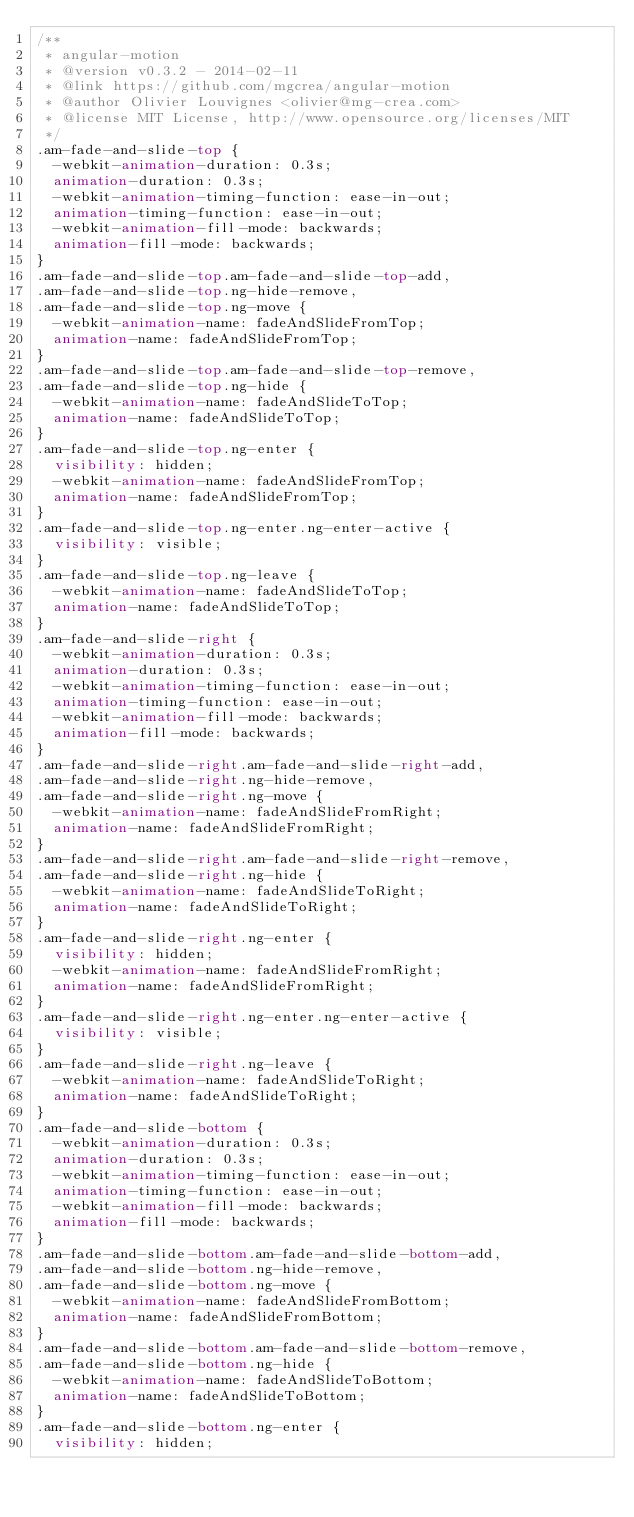Convert code to text. <code><loc_0><loc_0><loc_500><loc_500><_CSS_>/**
 * angular-motion
 * @version v0.3.2 - 2014-02-11
 * @link https://github.com/mgcrea/angular-motion
 * @author Olivier Louvignes <olivier@mg-crea.com>
 * @license MIT License, http://www.opensource.org/licenses/MIT
 */
.am-fade-and-slide-top {
  -webkit-animation-duration: 0.3s;
  animation-duration: 0.3s;
  -webkit-animation-timing-function: ease-in-out;
  animation-timing-function: ease-in-out;
  -webkit-animation-fill-mode: backwards;
  animation-fill-mode: backwards;
}
.am-fade-and-slide-top.am-fade-and-slide-top-add,
.am-fade-and-slide-top.ng-hide-remove,
.am-fade-and-slide-top.ng-move {
  -webkit-animation-name: fadeAndSlideFromTop;
  animation-name: fadeAndSlideFromTop;
}
.am-fade-and-slide-top.am-fade-and-slide-top-remove,
.am-fade-and-slide-top.ng-hide {
  -webkit-animation-name: fadeAndSlideToTop;
  animation-name: fadeAndSlideToTop;
}
.am-fade-and-slide-top.ng-enter {
  visibility: hidden;
  -webkit-animation-name: fadeAndSlideFromTop;
  animation-name: fadeAndSlideFromTop;
}
.am-fade-and-slide-top.ng-enter.ng-enter-active {
  visibility: visible;
}
.am-fade-and-slide-top.ng-leave {
  -webkit-animation-name: fadeAndSlideToTop;
  animation-name: fadeAndSlideToTop;
}
.am-fade-and-slide-right {
  -webkit-animation-duration: 0.3s;
  animation-duration: 0.3s;
  -webkit-animation-timing-function: ease-in-out;
  animation-timing-function: ease-in-out;
  -webkit-animation-fill-mode: backwards;
  animation-fill-mode: backwards;
}
.am-fade-and-slide-right.am-fade-and-slide-right-add,
.am-fade-and-slide-right.ng-hide-remove,
.am-fade-and-slide-right.ng-move {
  -webkit-animation-name: fadeAndSlideFromRight;
  animation-name: fadeAndSlideFromRight;
}
.am-fade-and-slide-right.am-fade-and-slide-right-remove,
.am-fade-and-slide-right.ng-hide {
  -webkit-animation-name: fadeAndSlideToRight;
  animation-name: fadeAndSlideToRight;
}
.am-fade-and-slide-right.ng-enter {
  visibility: hidden;
  -webkit-animation-name: fadeAndSlideFromRight;
  animation-name: fadeAndSlideFromRight;
}
.am-fade-and-slide-right.ng-enter.ng-enter-active {
  visibility: visible;
}
.am-fade-and-slide-right.ng-leave {
  -webkit-animation-name: fadeAndSlideToRight;
  animation-name: fadeAndSlideToRight;
}
.am-fade-and-slide-bottom {
  -webkit-animation-duration: 0.3s;
  animation-duration: 0.3s;
  -webkit-animation-timing-function: ease-in-out;
  animation-timing-function: ease-in-out;
  -webkit-animation-fill-mode: backwards;
  animation-fill-mode: backwards;
}
.am-fade-and-slide-bottom.am-fade-and-slide-bottom-add,
.am-fade-and-slide-bottom.ng-hide-remove,
.am-fade-and-slide-bottom.ng-move {
  -webkit-animation-name: fadeAndSlideFromBottom;
  animation-name: fadeAndSlideFromBottom;
}
.am-fade-and-slide-bottom.am-fade-and-slide-bottom-remove,
.am-fade-and-slide-bottom.ng-hide {
  -webkit-animation-name: fadeAndSlideToBottom;
  animation-name: fadeAndSlideToBottom;
}
.am-fade-and-slide-bottom.ng-enter {
  visibility: hidden;</code> 